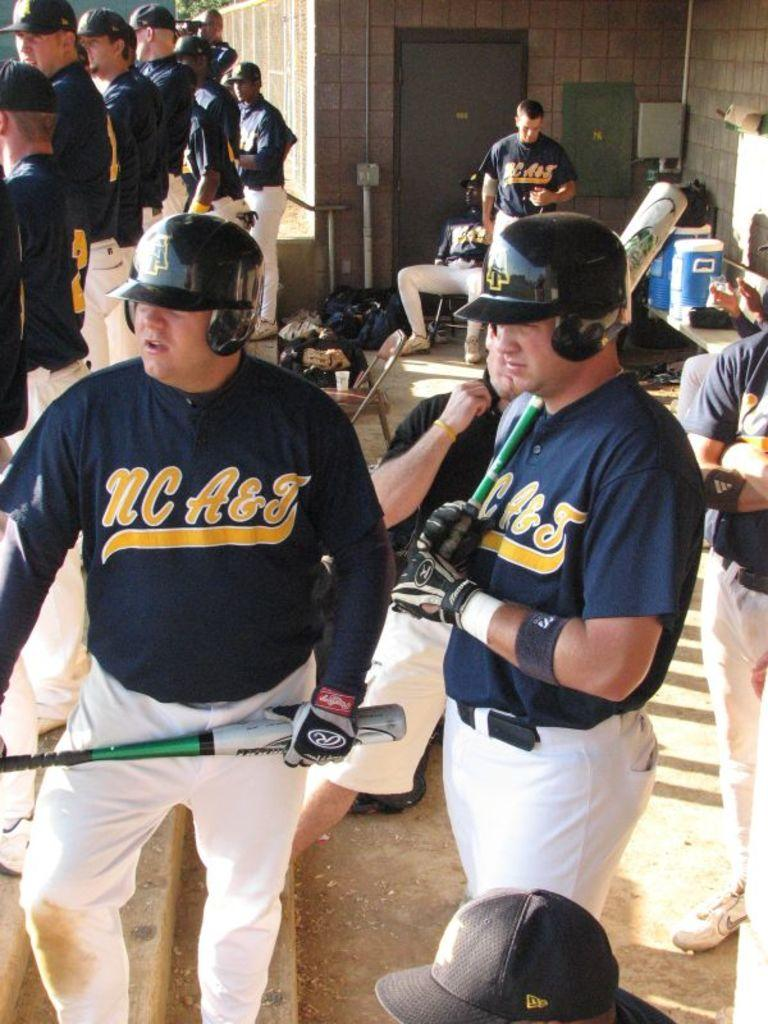<image>
Give a short and clear explanation of the subsequent image. Two men wearing NC A & T jerseys stand in a baseball dugout. 